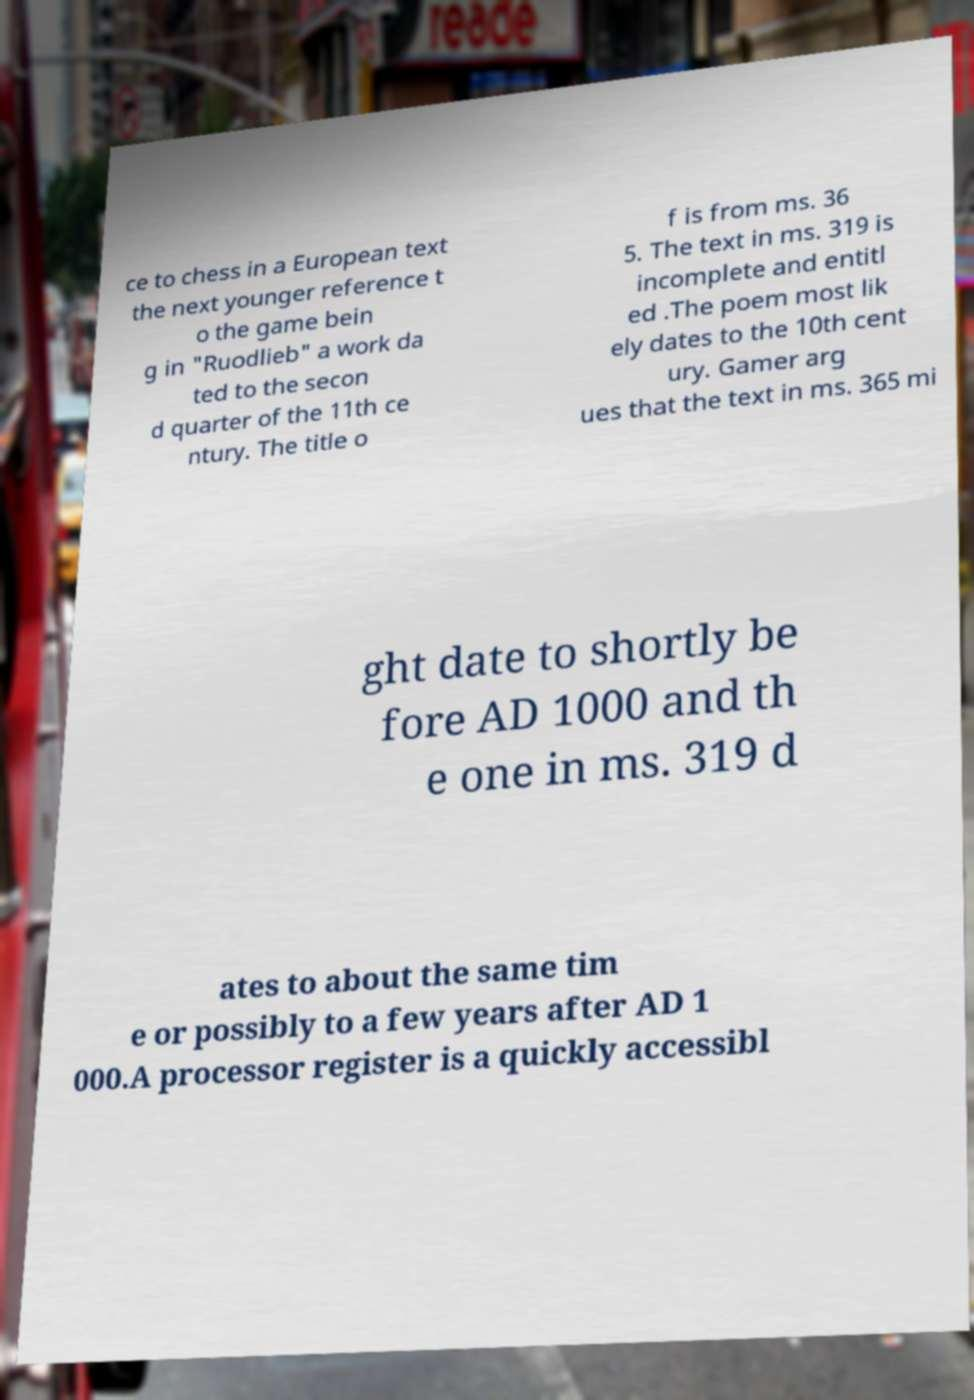For documentation purposes, I need the text within this image transcribed. Could you provide that? ce to chess in a European text the next younger reference t o the game bein g in "Ruodlieb" a work da ted to the secon d quarter of the 11th ce ntury. The title o f is from ms. 36 5. The text in ms. 319 is incomplete and entitl ed .The poem most lik ely dates to the 10th cent ury. Gamer arg ues that the text in ms. 365 mi ght date to shortly be fore AD 1000 and th e one in ms. 319 d ates to about the same tim e or possibly to a few years after AD 1 000.A processor register is a quickly accessibl 